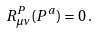Convert formula to latex. <formula><loc_0><loc_0><loc_500><loc_500>R ^ { P } _ { \mu \nu } ( P ^ { a } ) = 0 \, .</formula> 